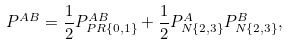<formula> <loc_0><loc_0><loc_500><loc_500>P ^ { A B } = \frac { 1 } { 2 } P ^ { A B } _ { P R \{ 0 , 1 \} } + \frac { 1 } { 2 } P ^ { A } _ { N \{ 2 , 3 \} } P ^ { B } _ { N \{ 2 , 3 \} } ,</formula> 